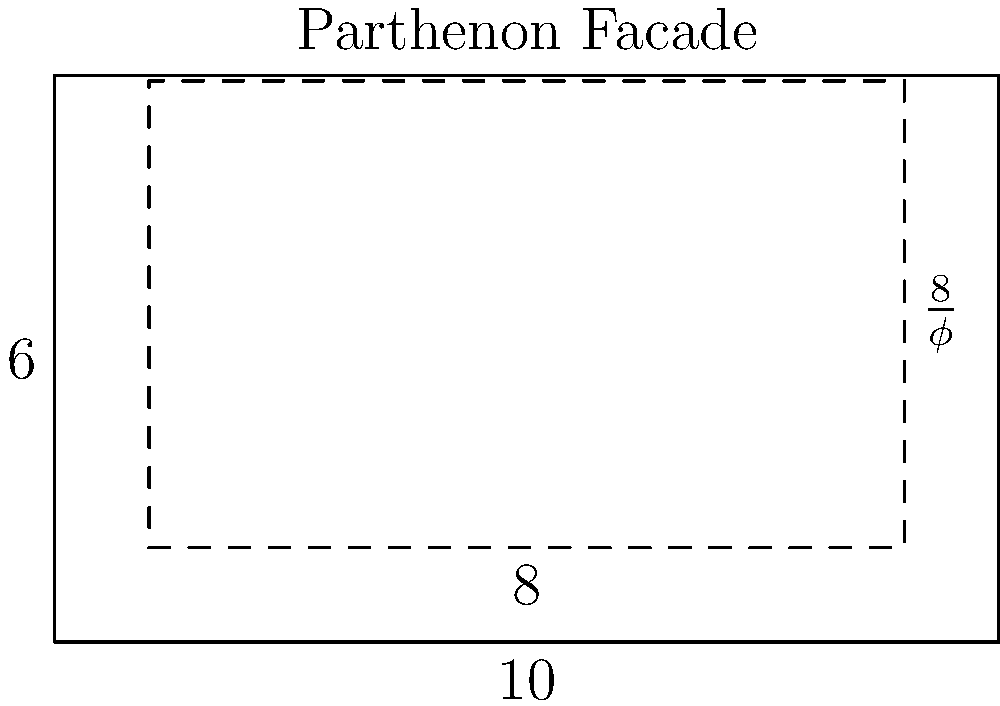In the diagram of the Parthenon's facade, a golden rectangle is inscribed within the structure. If the width of this golden rectangle is 8 units, what is the approximate height of the rectangle to the nearest hundredth? To solve this problem, we need to use the properties of the golden ratio and the given information:

1) The golden ratio, denoted by $\phi$ (phi), is defined as:
   $$\phi = \frac{1 + \sqrt{5}}{2} \approx 1.61803398875$$

2) In a golden rectangle, the ratio of the longer side to the shorter side is equal to $\phi$.

3) We're given that the width of the golden rectangle is 8 units.

4) Let's call the height of the rectangle $h$. According to the golden ratio property:
   $$\frac{8}{h} = \phi$$

5) To find $h$, we can rearrange this equation:
   $$h = \frac{8}{\phi}$$

6) Now, let's substitute the value of $\phi$ and calculate:
   $$h = \frac{8}{\frac{1 + \sqrt{5}}{2}} = \frac{16}{1 + \sqrt{5}} \approx 4.94427190999$$

7) Rounding to the nearest hundredth, we get 4.94.

This calculation demonstrates how the golden ratio was applied in ancient Greek architecture, particularly in the design of the Parthenon.
Answer: 4.94 